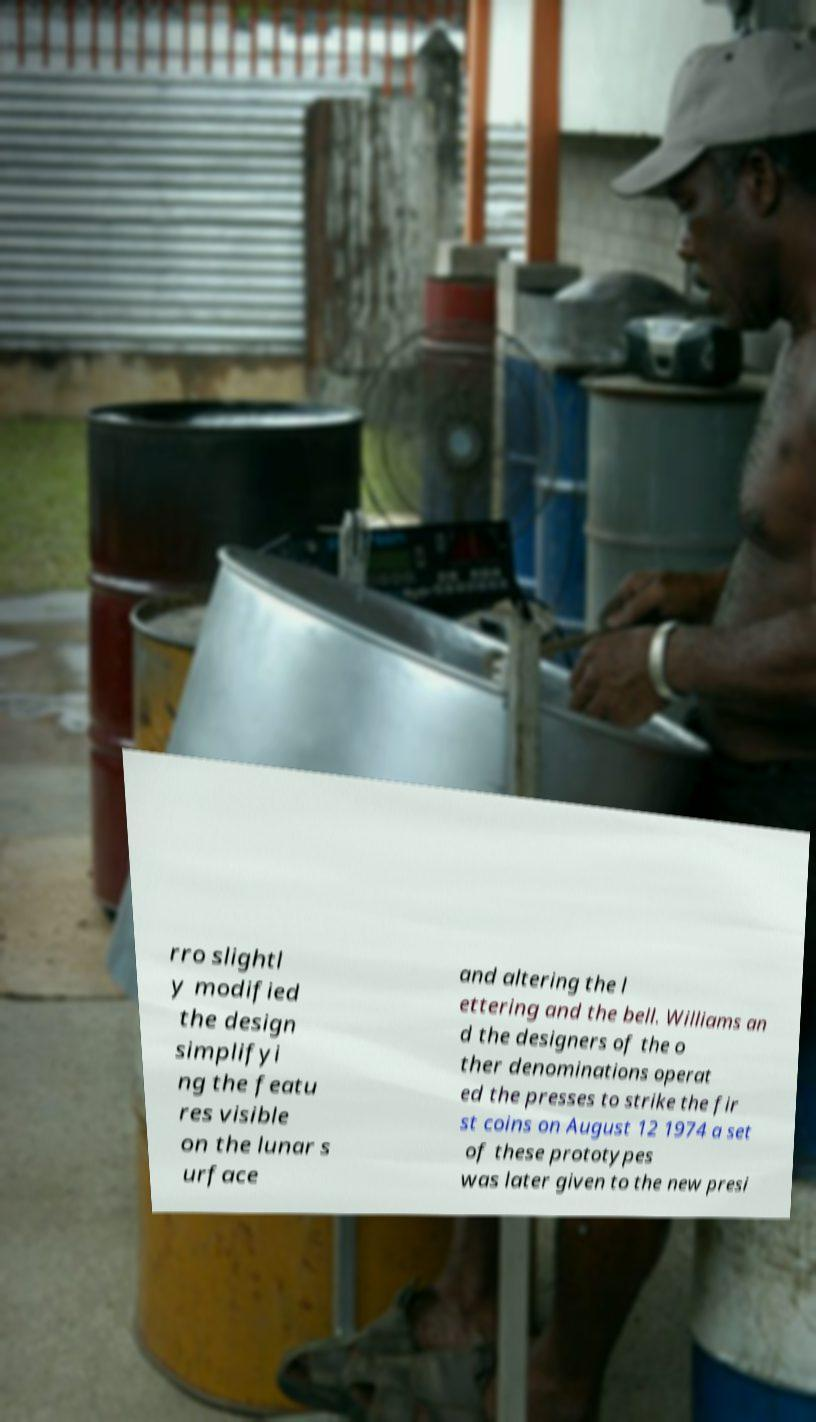What messages or text are displayed in this image? I need them in a readable, typed format. rro slightl y modified the design simplifyi ng the featu res visible on the lunar s urface and altering the l ettering and the bell. Williams an d the designers of the o ther denominations operat ed the presses to strike the fir st coins on August 12 1974 a set of these prototypes was later given to the new presi 